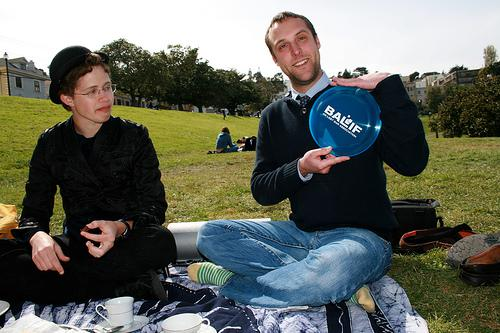Question: how many people are visible in this photo?
Choices:
A. 7.
B. 8.
C. 9.
D. 3.
Answer with the letter. Answer: D Question: what color is the grass?
Choices:
A. Red.
B. Blue.
C. Green.
D. Orange.
Answer with the letter. Answer: C Question: when was this photo taken?
Choices:
A. Sun down.
B. Early morning.
C. Outside, during the daytime.
D. Late evening.
Answer with the letter. Answer: C 